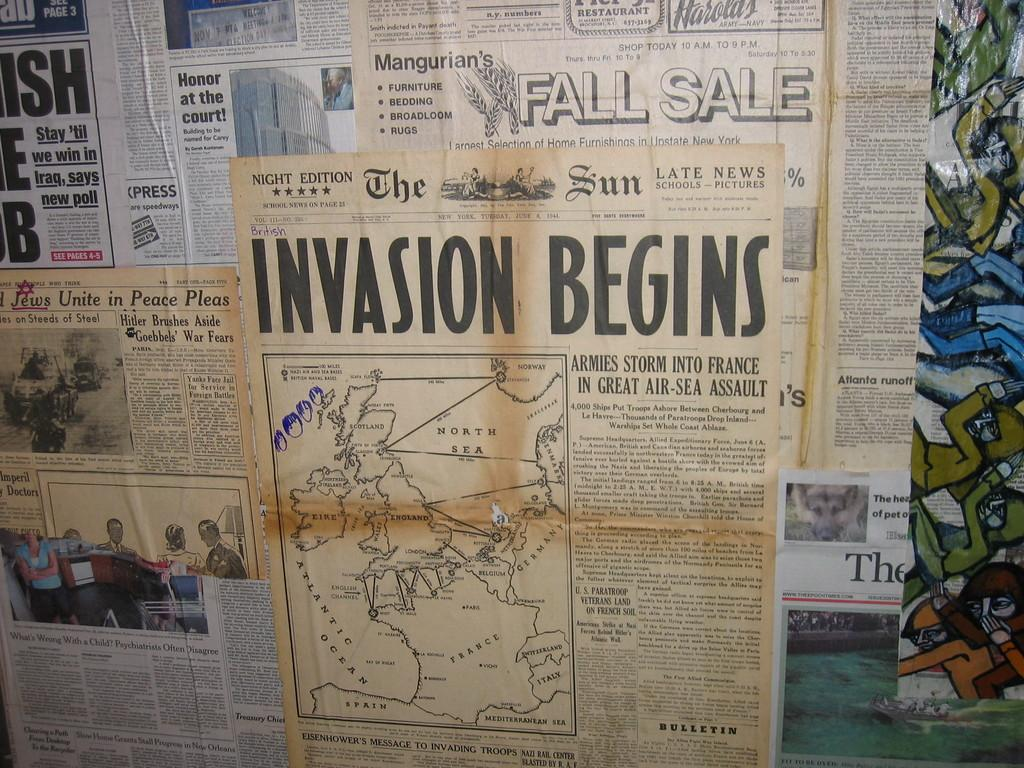What type of printed material can be seen in the image? There are newspapers in the image. Can you describe the content of the newspapers? The content of the newspapers cannot be determined from the image alone. Are the newspapers stacked or spread out in the image? The arrangement of the newspapers cannot be determined from the image alone. What is the taste of the muscle in the image? There is no muscle or taste present in the image, as it only features newspapers. 